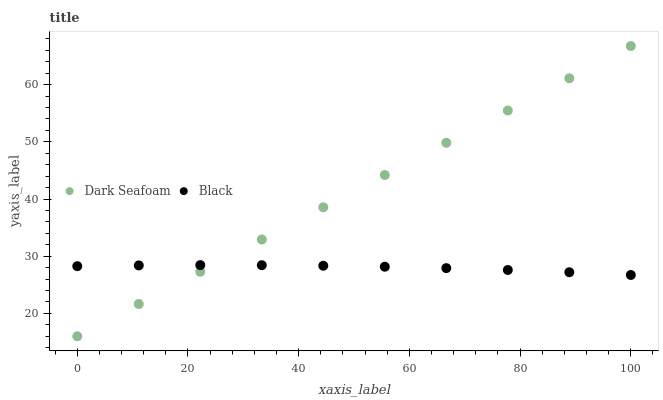Does Black have the minimum area under the curve?
Answer yes or no. Yes. Does Dark Seafoam have the maximum area under the curve?
Answer yes or no. Yes. Does Black have the maximum area under the curve?
Answer yes or no. No. Is Dark Seafoam the smoothest?
Answer yes or no. Yes. Is Black the roughest?
Answer yes or no. Yes. Is Black the smoothest?
Answer yes or no. No. Does Dark Seafoam have the lowest value?
Answer yes or no. Yes. Does Black have the lowest value?
Answer yes or no. No. Does Dark Seafoam have the highest value?
Answer yes or no. Yes. Does Black have the highest value?
Answer yes or no. No. Does Black intersect Dark Seafoam?
Answer yes or no. Yes. Is Black less than Dark Seafoam?
Answer yes or no. No. Is Black greater than Dark Seafoam?
Answer yes or no. No. 